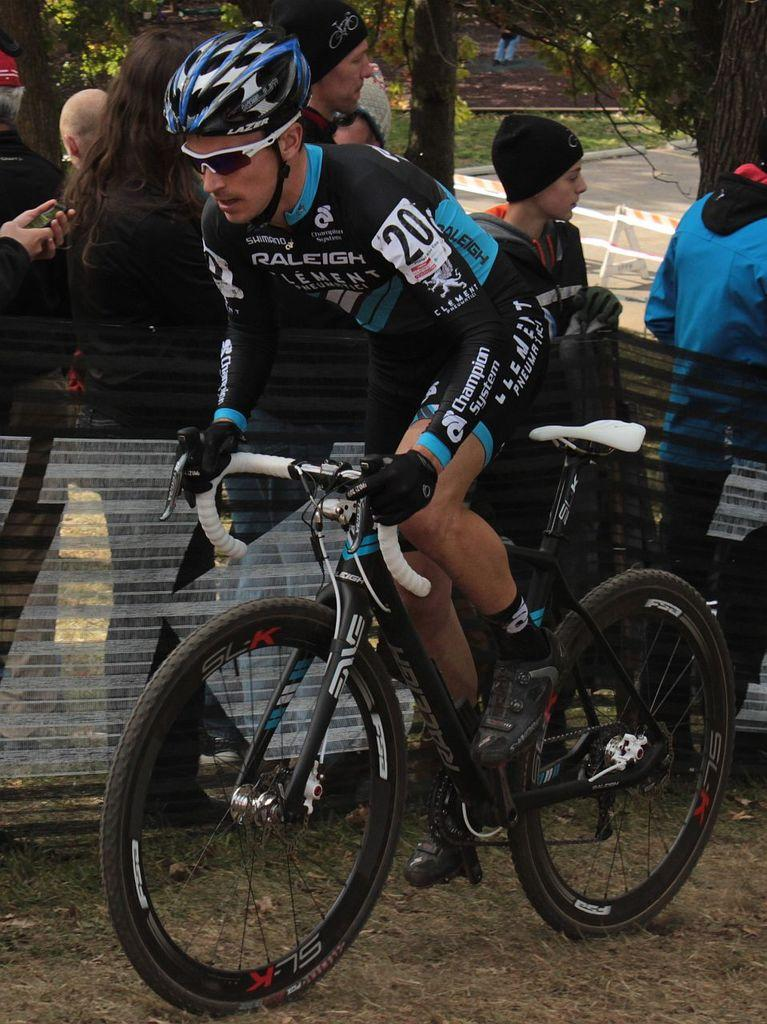What is the main subject of the image? There is a person riding a bicycle in the image. Can you describe the surroundings of the person riding the bicycle? There are other people standing in the background of the image, and there are trees and a road visible in the background. What type of table is being used to support the attention of the person riding the bicycle? There is no table present in the image, and the person riding the bicycle is not shown to be paying attention to anything specific. 